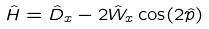<formula> <loc_0><loc_0><loc_500><loc_500>\hat { H } = \hat { D } _ { x } - 2 \hat { W } _ { x } \cos ( 2 \hat { p } )</formula> 